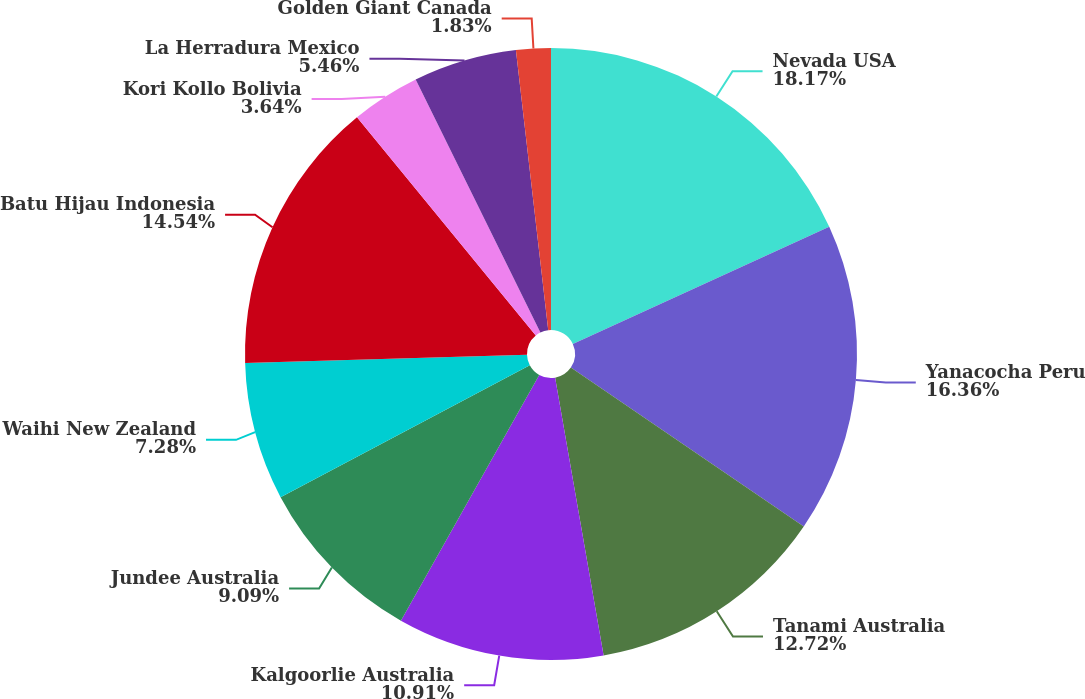<chart> <loc_0><loc_0><loc_500><loc_500><pie_chart><fcel>Nevada USA<fcel>Yanacocha Peru<fcel>Tanami Australia<fcel>Kalgoorlie Australia<fcel>Jundee Australia<fcel>Waihi New Zealand<fcel>Batu Hijau Indonesia<fcel>Kori Kollo Bolivia<fcel>La Herradura Mexico<fcel>Golden Giant Canada<nl><fcel>18.17%<fcel>16.36%<fcel>12.72%<fcel>10.91%<fcel>9.09%<fcel>7.28%<fcel>14.54%<fcel>3.64%<fcel>5.46%<fcel>1.83%<nl></chart> 